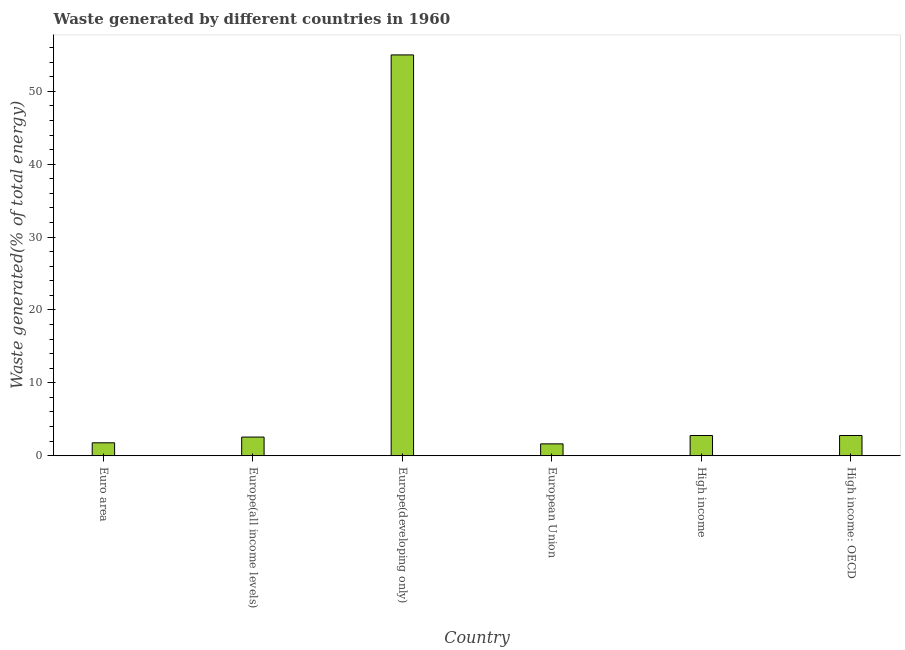What is the title of the graph?
Offer a very short reply. Waste generated by different countries in 1960. What is the label or title of the X-axis?
Your response must be concise. Country. What is the label or title of the Y-axis?
Provide a succinct answer. Waste generated(% of total energy). What is the amount of waste generated in Euro area?
Offer a very short reply. 1.77. Across all countries, what is the maximum amount of waste generated?
Provide a succinct answer. 54.99. Across all countries, what is the minimum amount of waste generated?
Ensure brevity in your answer.  1.63. In which country was the amount of waste generated maximum?
Give a very brief answer. Europe(developing only). In which country was the amount of waste generated minimum?
Give a very brief answer. European Union. What is the sum of the amount of waste generated?
Ensure brevity in your answer.  66.5. What is the average amount of waste generated per country?
Provide a succinct answer. 11.08. What is the median amount of waste generated?
Your answer should be very brief. 2.67. What is the ratio of the amount of waste generated in European Union to that in High income?
Provide a succinct answer. 0.59. Is the amount of waste generated in Euro area less than that in Europe(all income levels)?
Your answer should be very brief. Yes. What is the difference between the highest and the second highest amount of waste generated?
Your answer should be very brief. 52.22. Is the sum of the amount of waste generated in Euro area and European Union greater than the maximum amount of waste generated across all countries?
Your answer should be very brief. No. What is the difference between the highest and the lowest amount of waste generated?
Keep it short and to the point. 53.37. In how many countries, is the amount of waste generated greater than the average amount of waste generated taken over all countries?
Provide a succinct answer. 1. Are all the bars in the graph horizontal?
Your answer should be compact. No. What is the difference between two consecutive major ticks on the Y-axis?
Provide a succinct answer. 10. Are the values on the major ticks of Y-axis written in scientific E-notation?
Offer a very short reply. No. What is the Waste generated(% of total energy) of Euro area?
Your response must be concise. 1.77. What is the Waste generated(% of total energy) in Europe(all income levels)?
Provide a succinct answer. 2.56. What is the Waste generated(% of total energy) of Europe(developing only)?
Keep it short and to the point. 54.99. What is the Waste generated(% of total energy) in European Union?
Make the answer very short. 1.63. What is the Waste generated(% of total energy) in High income?
Ensure brevity in your answer.  2.77. What is the Waste generated(% of total energy) of High income: OECD?
Your answer should be compact. 2.77. What is the difference between the Waste generated(% of total energy) in Euro area and Europe(all income levels)?
Make the answer very short. -0.79. What is the difference between the Waste generated(% of total energy) in Euro area and Europe(developing only)?
Offer a terse response. -53.22. What is the difference between the Waste generated(% of total energy) in Euro area and European Union?
Provide a short and direct response. 0.15. What is the difference between the Waste generated(% of total energy) in Euro area and High income?
Provide a short and direct response. -1. What is the difference between the Waste generated(% of total energy) in Euro area and High income: OECD?
Keep it short and to the point. -1. What is the difference between the Waste generated(% of total energy) in Europe(all income levels) and Europe(developing only)?
Your response must be concise. -52.43. What is the difference between the Waste generated(% of total energy) in Europe(all income levels) and European Union?
Keep it short and to the point. 0.93. What is the difference between the Waste generated(% of total energy) in Europe(all income levels) and High income?
Ensure brevity in your answer.  -0.21. What is the difference between the Waste generated(% of total energy) in Europe(all income levels) and High income: OECD?
Offer a very short reply. -0.21. What is the difference between the Waste generated(% of total energy) in Europe(developing only) and European Union?
Offer a terse response. 53.37. What is the difference between the Waste generated(% of total energy) in Europe(developing only) and High income?
Keep it short and to the point. 52.22. What is the difference between the Waste generated(% of total energy) in Europe(developing only) and High income: OECD?
Ensure brevity in your answer.  52.22. What is the difference between the Waste generated(% of total energy) in European Union and High income?
Offer a terse response. -1.15. What is the difference between the Waste generated(% of total energy) in European Union and High income: OECD?
Keep it short and to the point. -1.15. What is the ratio of the Waste generated(% of total energy) in Euro area to that in Europe(all income levels)?
Your answer should be compact. 0.69. What is the ratio of the Waste generated(% of total energy) in Euro area to that in Europe(developing only)?
Offer a very short reply. 0.03. What is the ratio of the Waste generated(% of total energy) in Euro area to that in European Union?
Your answer should be very brief. 1.09. What is the ratio of the Waste generated(% of total energy) in Euro area to that in High income?
Your answer should be very brief. 0.64. What is the ratio of the Waste generated(% of total energy) in Euro area to that in High income: OECD?
Your answer should be compact. 0.64. What is the ratio of the Waste generated(% of total energy) in Europe(all income levels) to that in Europe(developing only)?
Provide a succinct answer. 0.05. What is the ratio of the Waste generated(% of total energy) in Europe(all income levels) to that in European Union?
Provide a succinct answer. 1.57. What is the ratio of the Waste generated(% of total energy) in Europe(all income levels) to that in High income?
Keep it short and to the point. 0.92. What is the ratio of the Waste generated(% of total energy) in Europe(all income levels) to that in High income: OECD?
Give a very brief answer. 0.92. What is the ratio of the Waste generated(% of total energy) in Europe(developing only) to that in European Union?
Your answer should be very brief. 33.8. What is the ratio of the Waste generated(% of total energy) in Europe(developing only) to that in High income?
Make the answer very short. 19.83. What is the ratio of the Waste generated(% of total energy) in Europe(developing only) to that in High income: OECD?
Ensure brevity in your answer.  19.83. What is the ratio of the Waste generated(% of total energy) in European Union to that in High income?
Your response must be concise. 0.59. What is the ratio of the Waste generated(% of total energy) in European Union to that in High income: OECD?
Your response must be concise. 0.59. 